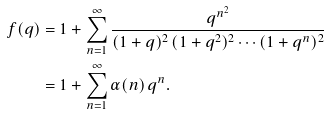Convert formula to latex. <formula><loc_0><loc_0><loc_500><loc_500>f ( q ) & = 1 + \sum _ { n = 1 } ^ { \infty } \frac { q ^ { n ^ { 2 } } } { ( 1 + q ) ^ { 2 } \, ( 1 + q ^ { 2 } ) ^ { 2 } \cdots ( 1 + q ^ { n } ) ^ { 2 } } \\ & = 1 + \sum _ { n = 1 } ^ { \infty } \alpha ( n ) \, q ^ { n } .</formula> 